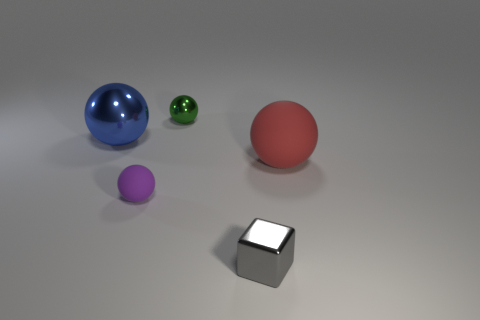Are there fewer small cyan rubber things than big red spheres?
Give a very brief answer. Yes. How many other objects are the same color as the big shiny thing?
Ensure brevity in your answer.  0. What number of big red spheres are there?
Your answer should be very brief. 1. Is the number of big blue spheres in front of the red matte sphere less than the number of tiny purple matte things?
Offer a terse response. Yes. Is the material of the large sphere that is behind the big rubber thing the same as the red object?
Your answer should be very brief. No. What shape is the matte object that is on the left side of the shiny object that is in front of the ball that is to the right of the tiny green shiny thing?
Keep it short and to the point. Sphere. Are there any blue metal objects of the same size as the purple object?
Your response must be concise. No. The gray metal block is what size?
Provide a succinct answer. Small. What number of matte things are the same size as the red ball?
Your answer should be compact. 0. Is the number of green balls that are in front of the purple thing less than the number of big matte balls left of the tiny gray block?
Offer a very short reply. No. 